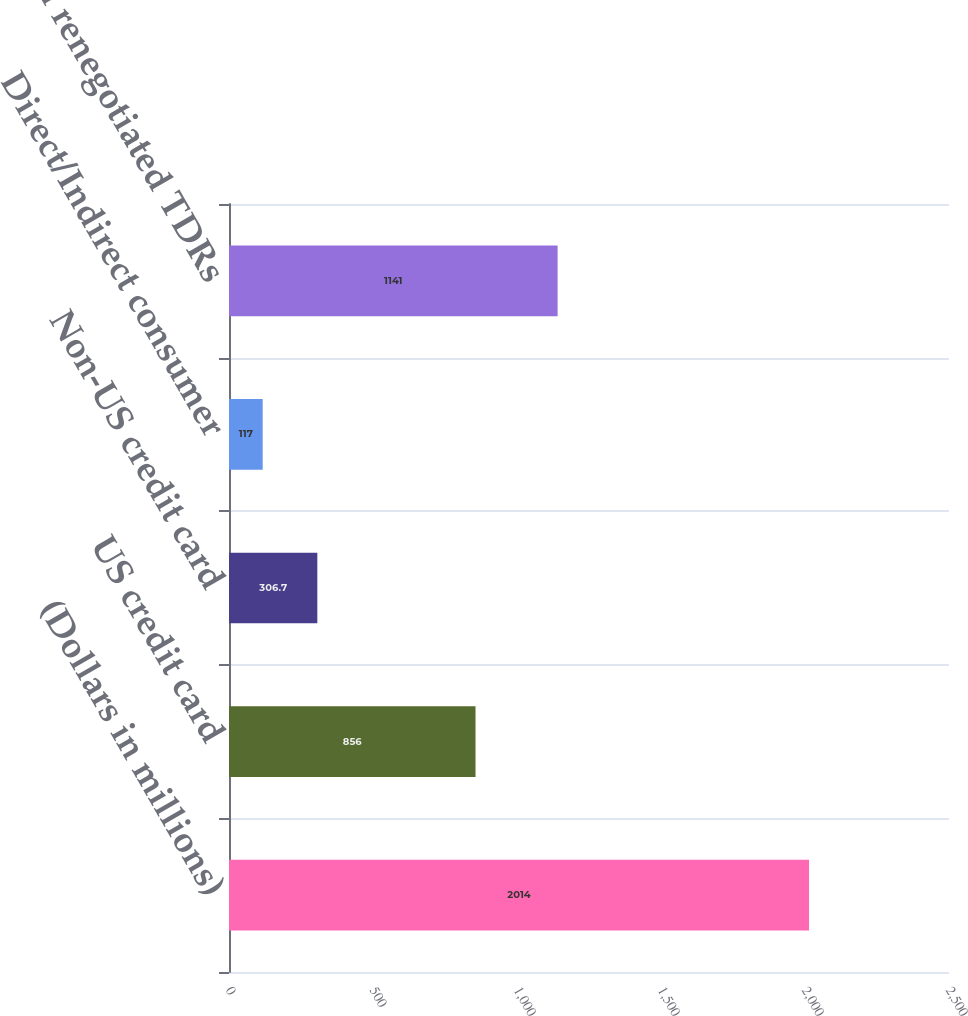Convert chart. <chart><loc_0><loc_0><loc_500><loc_500><bar_chart><fcel>(Dollars in millions)<fcel>US credit card<fcel>Non-US credit card<fcel>Direct/Indirect consumer<fcel>Total renegotiated TDRs<nl><fcel>2014<fcel>856<fcel>306.7<fcel>117<fcel>1141<nl></chart> 